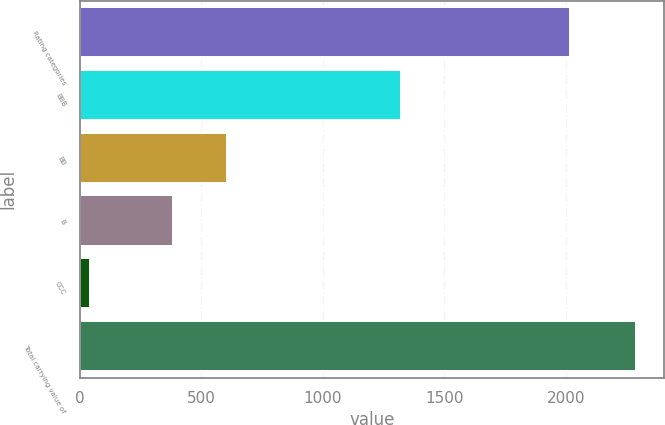Convert chart to OTSL. <chart><loc_0><loc_0><loc_500><loc_500><bar_chart><fcel>Rating categories<fcel>BBB<fcel>BB<fcel>B<fcel>CCC<fcel>Total carrying value of<nl><fcel>2016<fcel>1324<fcel>607.5<fcel>383<fcel>44<fcel>2289<nl></chart> 